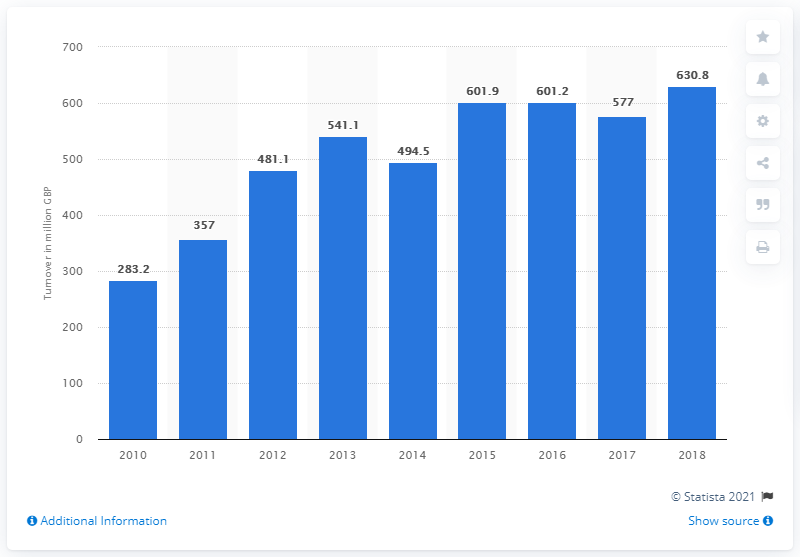Indicate a few pertinent items in this graphic. Alexander Dennis' turnover in 2018 was approximately 630.8 million dollars. 